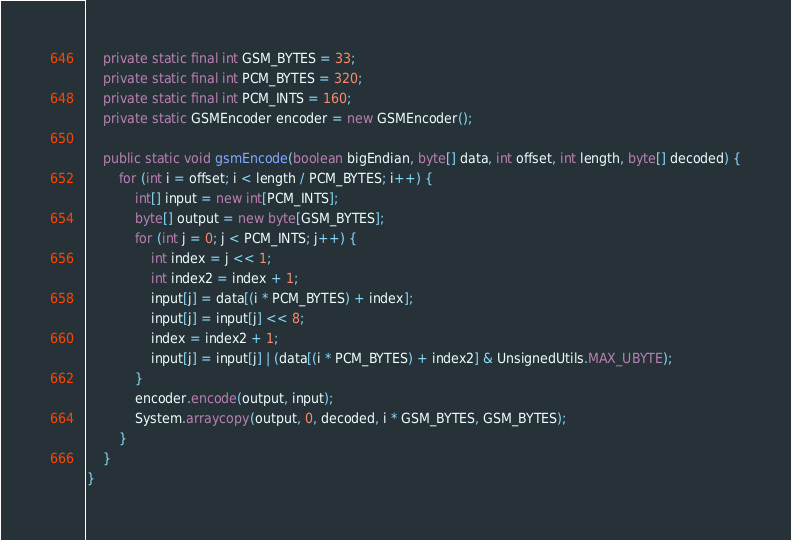Convert code to text. <code><loc_0><loc_0><loc_500><loc_500><_Java_>    private static final int GSM_BYTES = 33;
    private static final int PCM_BYTES = 320;
    private static final int PCM_INTS = 160;
    private static GSMEncoder encoder = new GSMEncoder();

    public static void gsmEncode(boolean bigEndian, byte[] data, int offset, int length, byte[] decoded) {
        for (int i = offset; i < length / PCM_BYTES; i++) {
            int[] input = new int[PCM_INTS];
            byte[] output = new byte[GSM_BYTES];
            for (int j = 0; j < PCM_INTS; j++) {
                int index = j << 1;
                int index2 = index + 1;
                input[j] = data[(i * PCM_BYTES) + index];
                input[j] = input[j] << 8;
                index = index2 + 1;
                input[j] = input[j] | (data[(i * PCM_BYTES) + index2] & UnsignedUtils.MAX_UBYTE);
            }
            encoder.encode(output, input);
            System.arraycopy(output, 0, decoded, i * GSM_BYTES, GSM_BYTES);
        }
    }
}
</code> 